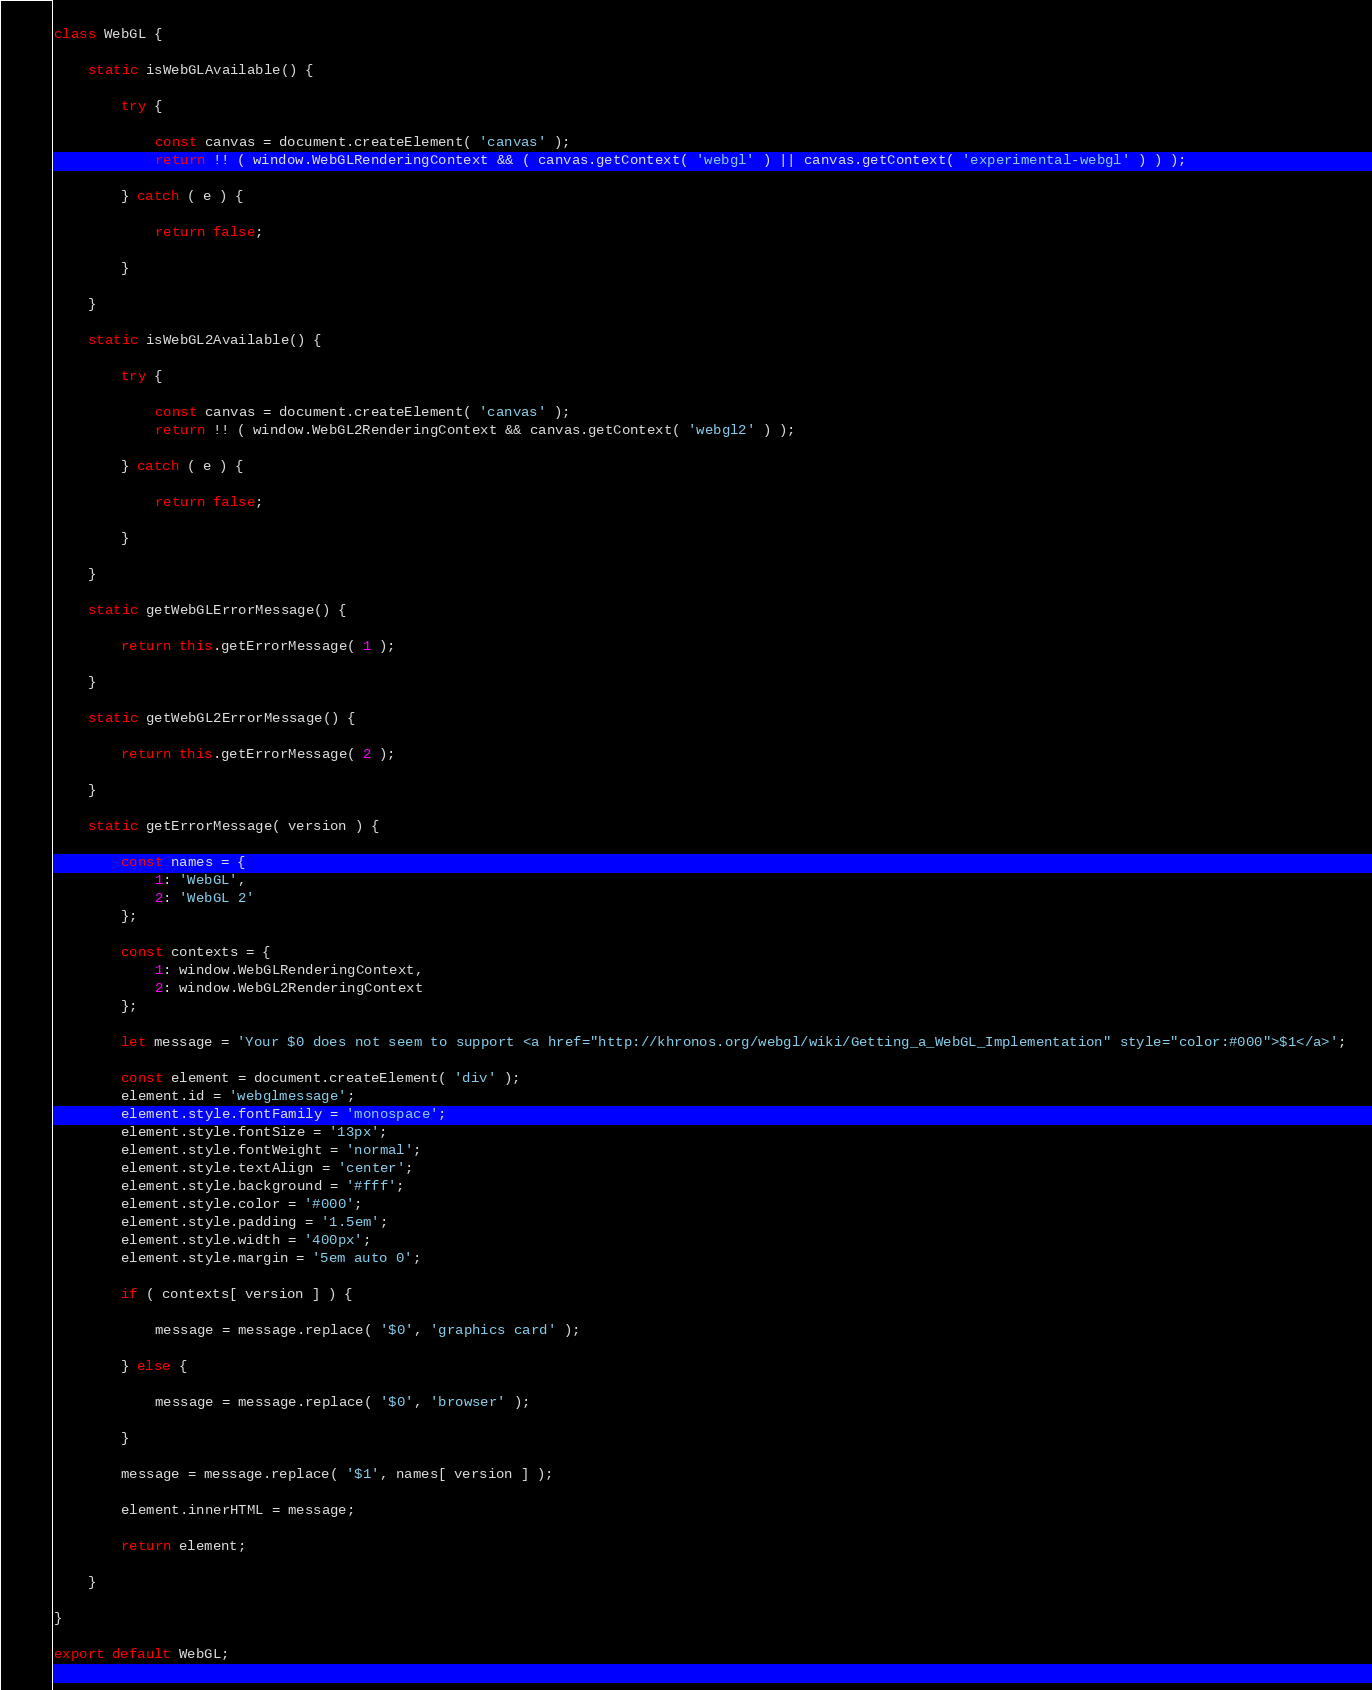<code> <loc_0><loc_0><loc_500><loc_500><_JavaScript_>class WebGL {

	static isWebGLAvailable() {

		try {

			const canvas = document.createElement( 'canvas' );
			return !! ( window.WebGLRenderingContext && ( canvas.getContext( 'webgl' ) || canvas.getContext( 'experimental-webgl' ) ) );

		} catch ( e ) {

			return false;

		}

	}

	static isWebGL2Available() {

		try {

			const canvas = document.createElement( 'canvas' );
			return !! ( window.WebGL2RenderingContext && canvas.getContext( 'webgl2' ) );

		} catch ( e ) {

			return false;

		}

	}

	static getWebGLErrorMessage() {

		return this.getErrorMessage( 1 );

	}

	static getWebGL2ErrorMessage() {

		return this.getErrorMessage( 2 );

	}

	static getErrorMessage( version ) {

		const names = {
			1: 'WebGL',
			2: 'WebGL 2'
		};

		const contexts = {
			1: window.WebGLRenderingContext,
			2: window.WebGL2RenderingContext
		};

		let message = 'Your $0 does not seem to support <a href="http://khronos.org/webgl/wiki/Getting_a_WebGL_Implementation" style="color:#000">$1</a>';

		const element = document.createElement( 'div' );
		element.id = 'webglmessage';
		element.style.fontFamily = 'monospace';
		element.style.fontSize = '13px';
		element.style.fontWeight = 'normal';
		element.style.textAlign = 'center';
		element.style.background = '#fff';
		element.style.color = '#000';
		element.style.padding = '1.5em';
		element.style.width = '400px';
		element.style.margin = '5em auto 0';

		if ( contexts[ version ] ) {

			message = message.replace( '$0', 'graphics card' );

		} else {

			message = message.replace( '$0', 'browser' );

		}

		message = message.replace( '$1', names[ version ] );

		element.innerHTML = message;

		return element;

	}

}

export default WebGL;
</code> 